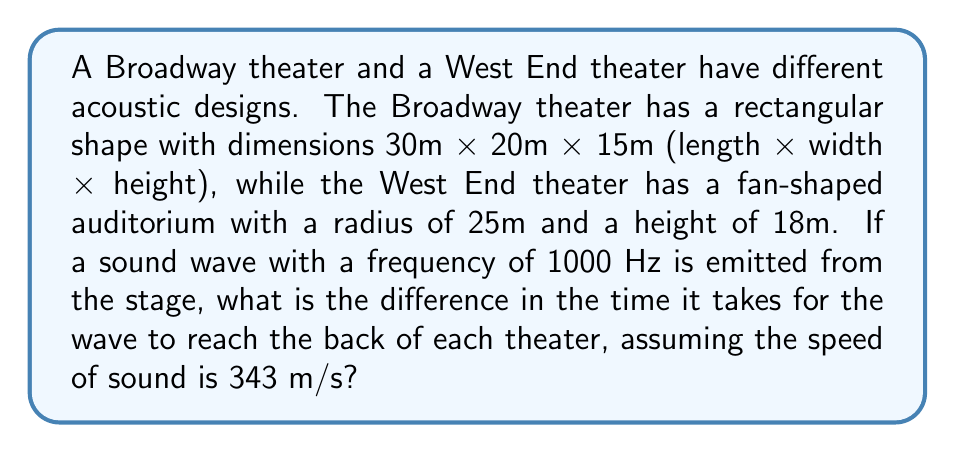Show me your answer to this math problem. To solve this problem, we need to calculate the time it takes for the sound wave to travel from the stage to the back of each theater. We'll use the formula:

$$t = \frac{d}{v}$$

Where:
$t$ = time
$d$ = distance
$v$ = velocity (speed of sound)

Step 1: Calculate the distance for the Broadway theater
The length of the Broadway theater is 30m, so this is our distance.

$$t_{Broadway} = \frac{30\text{ m}}{343\text{ m/s}} = 0.0875\text{ s}$$

Step 2: Calculate the distance for the West End theater
For the fan-shaped West End theater, the distance is the radius, which is 25m.

$$t_{West End} = \frac{25\text{ m}}{343\text{ m/s}} = 0.0729\text{ s}$$

Step 3: Calculate the difference in time
$$\Delta t = t_{Broadway} - t_{West End} = 0.0875\text{ s} - 0.0729\text{ s} = 0.0146\text{ s}$$

Converting to milliseconds:
$$0.0146\text{ s} \times 1000 = 14.6\text{ ms}$$
Answer: 14.6 ms 